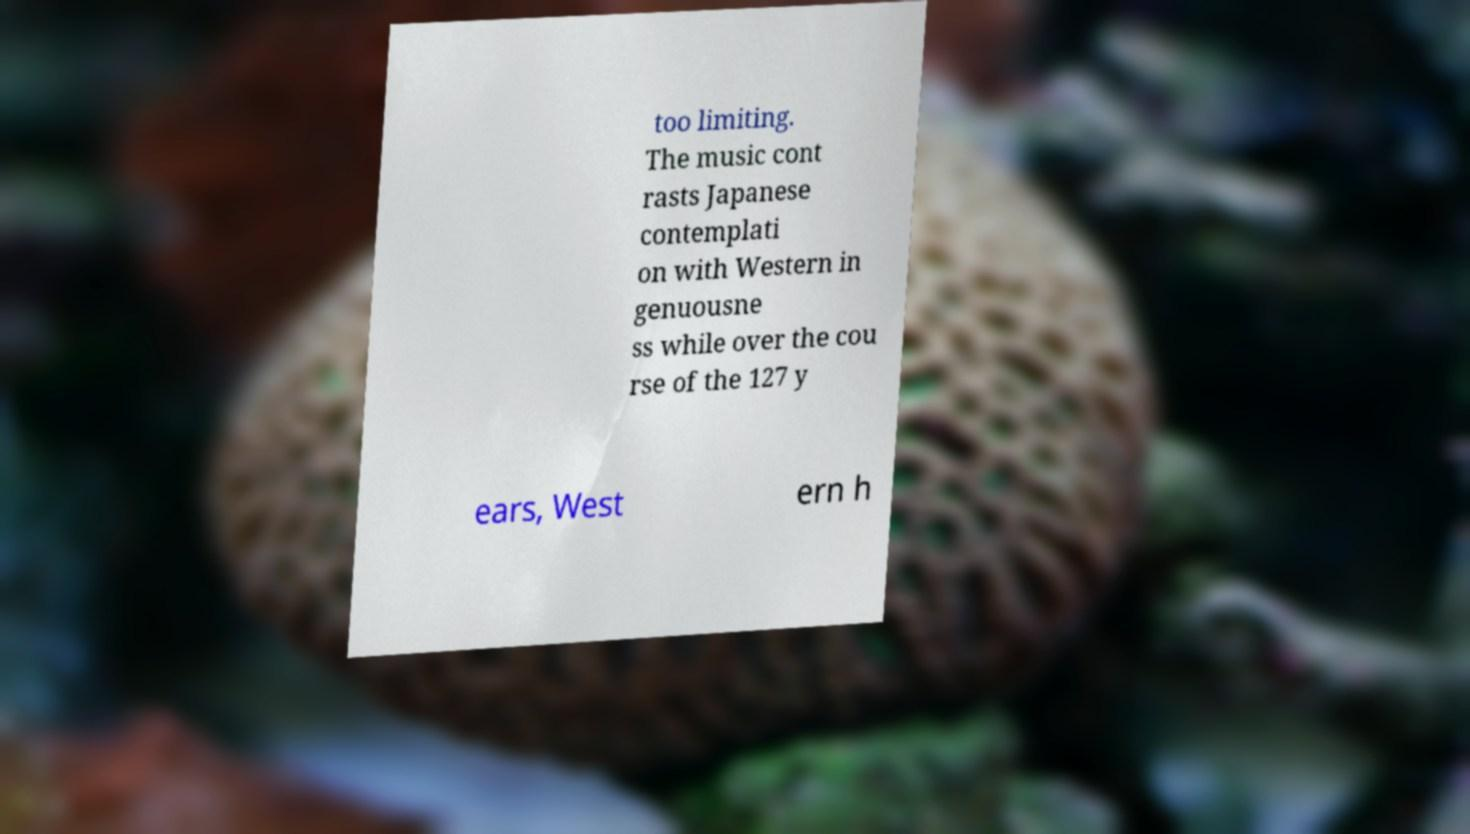Can you read and provide the text displayed in the image?This photo seems to have some interesting text. Can you extract and type it out for me? too limiting. The music cont rasts Japanese contemplati on with Western in genuousne ss while over the cou rse of the 127 y ears, West ern h 